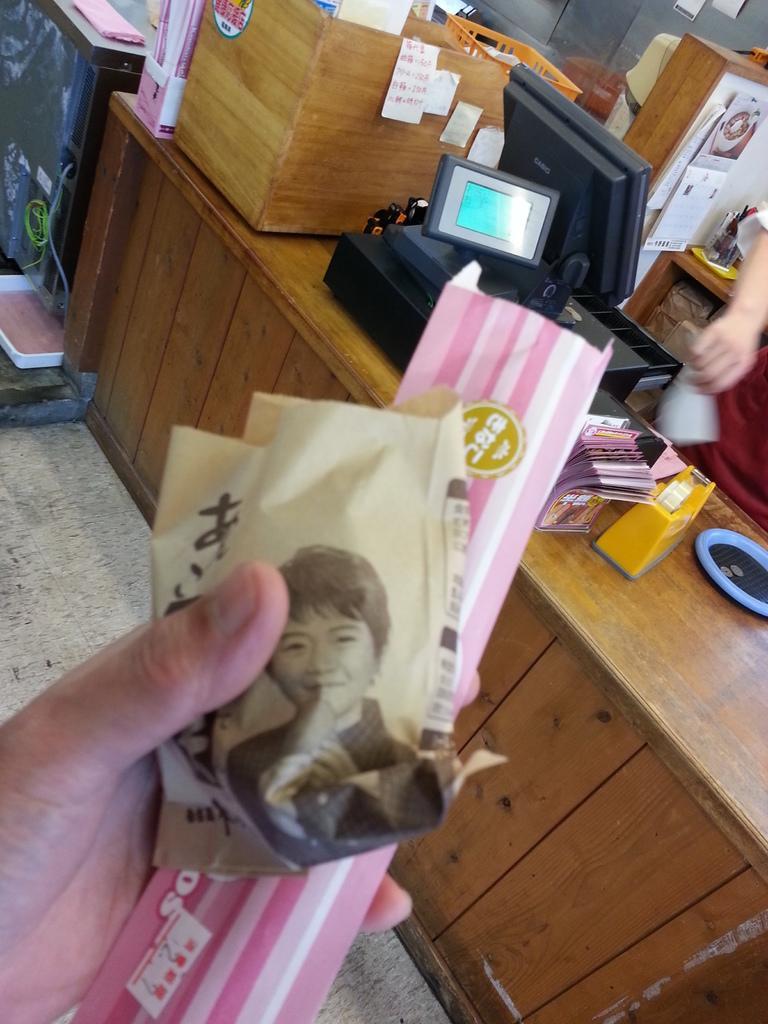Can you describe this image briefly? There is a wooden table and a computer, some papers, a plaster and other things are kept on the table, there is a person standing in front of the table and he is holding two items with his hand, behind the table there is a person and beside the person there is a basket and some other things. 